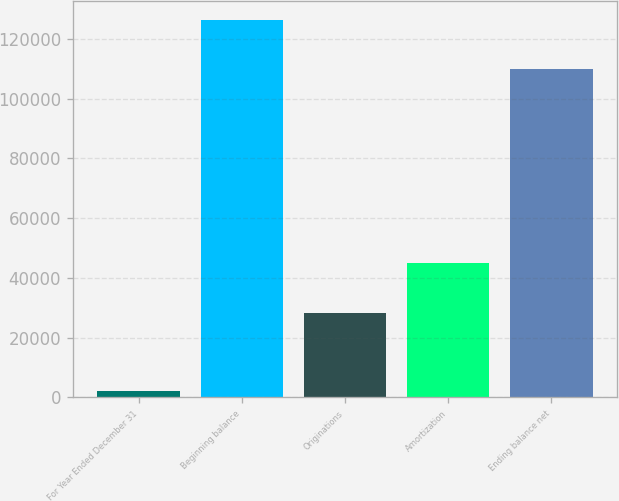Convert chart. <chart><loc_0><loc_0><loc_500><loc_500><bar_chart><fcel>For Year Ended December 31<fcel>Beginning balance<fcel>Originations<fcel>Amortization<fcel>Ending balance net<nl><fcel>2014<fcel>126377<fcel>28285<fcel>45080<fcel>109871<nl></chart> 